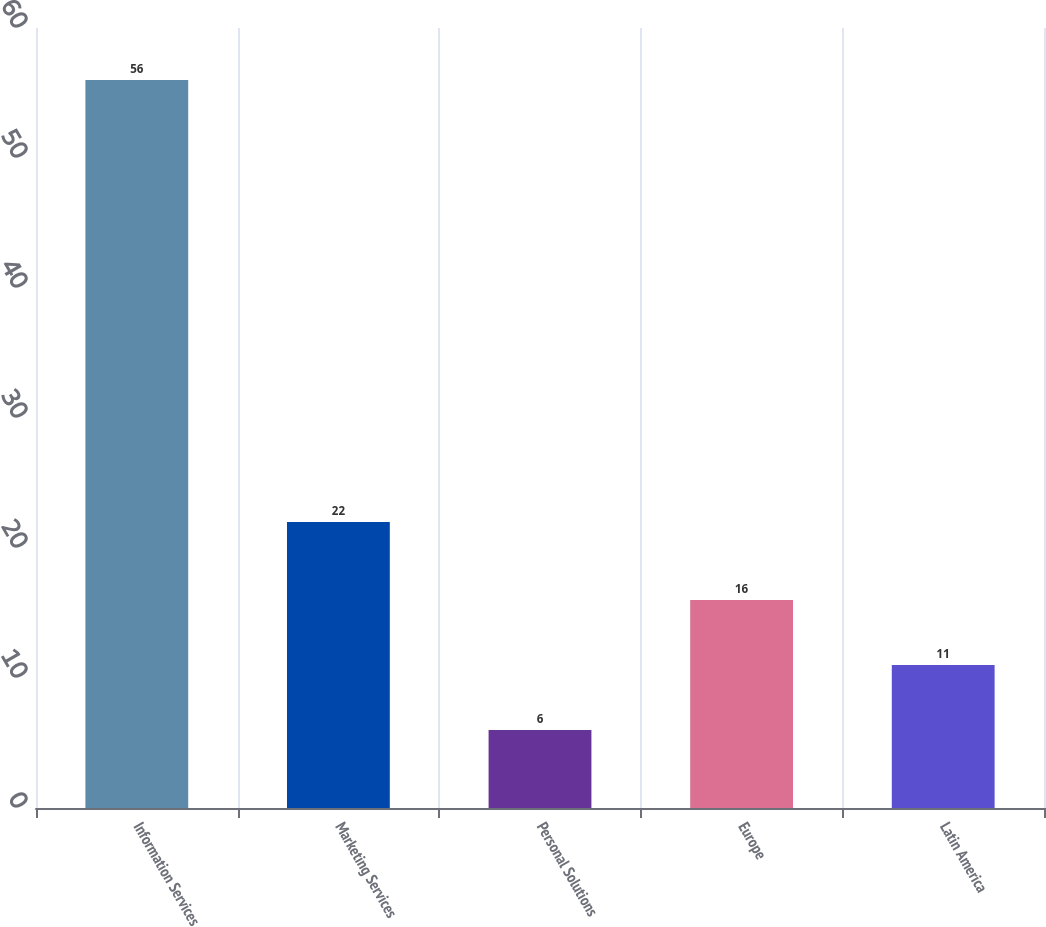Convert chart. <chart><loc_0><loc_0><loc_500><loc_500><bar_chart><fcel>Information Services<fcel>Marketing Services<fcel>Personal Solutions<fcel>Europe<fcel>Latin America<nl><fcel>56<fcel>22<fcel>6<fcel>16<fcel>11<nl></chart> 